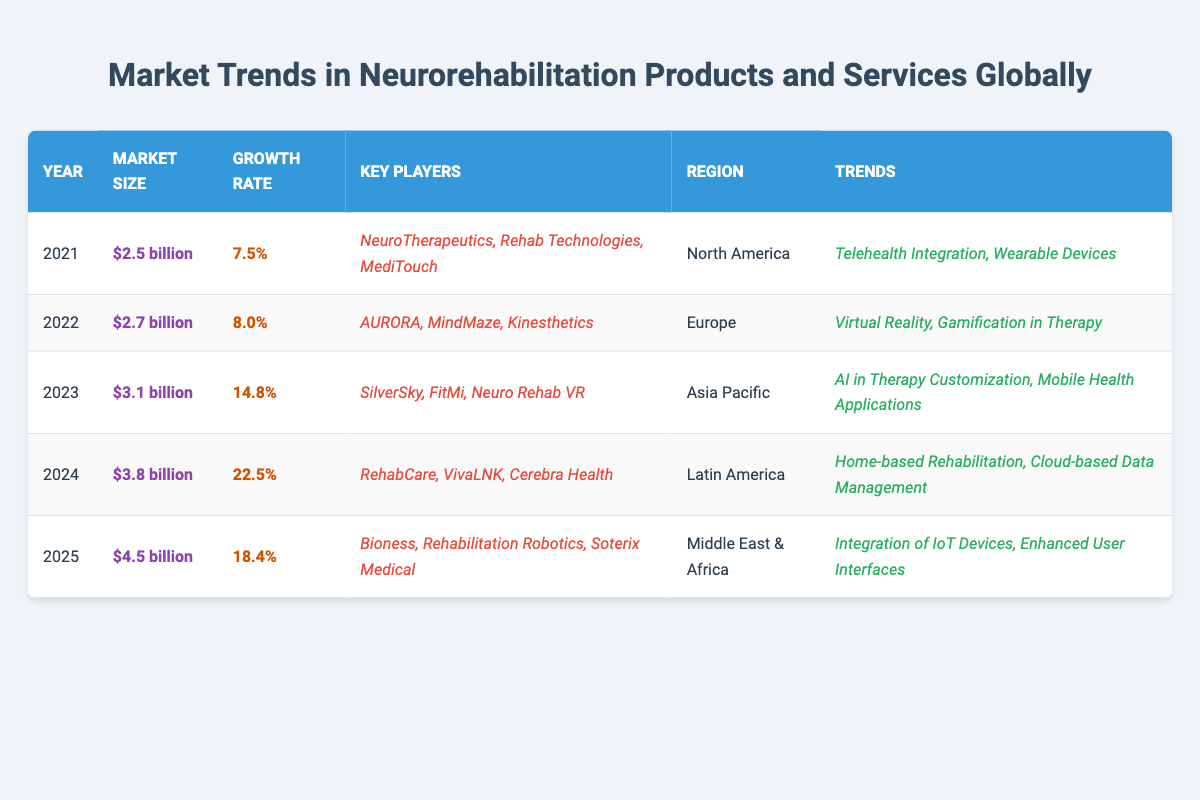What is the global market size for neurorehabilitation products and services in 2023? The table indicates that in 2023, the global market size is reported as $3.1 billion.
Answer: $3.1 billion What is the projected growth rate for the market in 2024? According to the table, the projected growth rate for 2024 is 22.5%.
Answer: 22.5% Which region saw the highest growth rate from 2021 to 2023? We look at the growth rates: 2021 (7.5%), 2022 (8.0%), and 2023 (14.8%). The highest growth rate in this timeframe is 14.8% in 2023.
Answer: Asia Pacific How many key players are listed for the year 2022? The table states that there are three key players listed for the year 2022, which are AURORA, MindMaze, and Kinesthetics.
Answer: 3 What is the average global market size from 2021 to 2023? The market sizes for 2021, 2022, and 2023 are $2.5 billion, $2.7 billion, and $3.1 billion respectively. Adding these amounts gives $2.5 + $2.7 + $3.1 = $8.3 billion. Dividing by 3 data points gives an average of $8.3 billion / 3 = $2.77 billion.
Answer: $2.77 billion Is the trend of AI in therapy customization present in the data for 2022? By checking the trends listed for 2022, which are "Virtual Reality, Gamification in Therapy," we confirm that "AI in Therapy Customization" is not included.
Answer: No Which year showed the highest projected market size, and what is that size? From the projections presented for 2024 and 2025, 2025 has the largest projected market size of $4.5 billion.
Answer: $4.5 billion How many market segments from the data are associated with trends involving technology in 2024? The trends for 2024 are "Home-based Rehabilitation" and "Cloud-based Data Management." Both are technology-related, thus giving a total of 2.
Answer: 2 Compare the market size in 2021 to that in 2025. What is the difference? The market size in 2021 is $2.5 billion and in 2025 it is $4.5 billion. The difference is calculated as follows: $4.5 billion - $2.5 billion = $2.0 billion.
Answer: $2.0 billion What key players are common across the Asia Pacific region for 2023? The table specifies the key players for 2023 as SilverSky, FitMi, and Neuro Rehab VR. There are no overlaps listed with other regions in the provided data.
Answer: N/A (specific to 2023 only) 